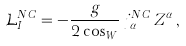Convert formula to latex. <formula><loc_0><loc_0><loc_500><loc_500>\mathcal { L } _ { I } ^ { N C } = - \frac { g } { 2 \cos _ { W } } \, j ^ { N C } _ { \alpha } \, Z ^ { \alpha } \, ,</formula> 